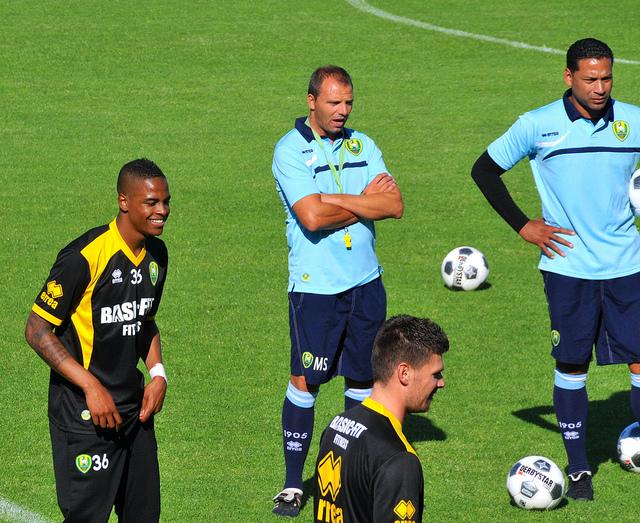What is the man on the left doing?
Keep it brief. Smiling. Are all of these men on the same team?
Be succinct. No. Which man has a whistle?
Short answer required. Coach. 